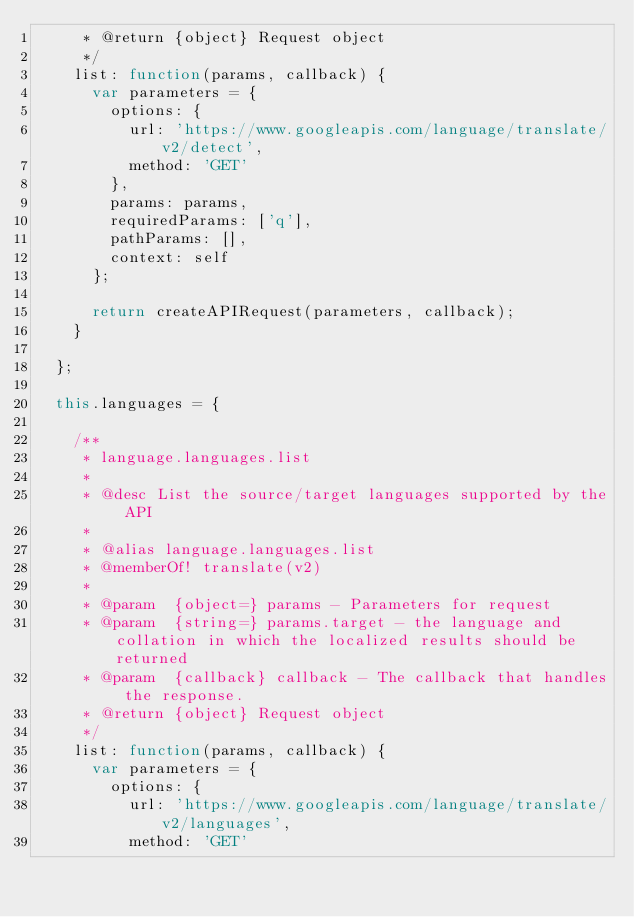<code> <loc_0><loc_0><loc_500><loc_500><_JavaScript_>     * @return {object} Request object
     */
    list: function(params, callback) {
      var parameters = {
        options: {
          url: 'https://www.googleapis.com/language/translate/v2/detect',
          method: 'GET'
        },
        params: params,
        requiredParams: ['q'],
        pathParams: [],
        context: self
      };

      return createAPIRequest(parameters, callback);
    }

  };

  this.languages = {

    /**
     * language.languages.list
     *
     * @desc List the source/target languages supported by the API
     *
     * @alias language.languages.list
     * @memberOf! translate(v2)
     *
     * @param  {object=} params - Parameters for request
     * @param  {string=} params.target - the language and collation in which the localized results should be returned
     * @param  {callback} callback - The callback that handles the response.
     * @return {object} Request object
     */
    list: function(params, callback) {
      var parameters = {
        options: {
          url: 'https://www.googleapis.com/language/translate/v2/languages',
          method: 'GET'</code> 